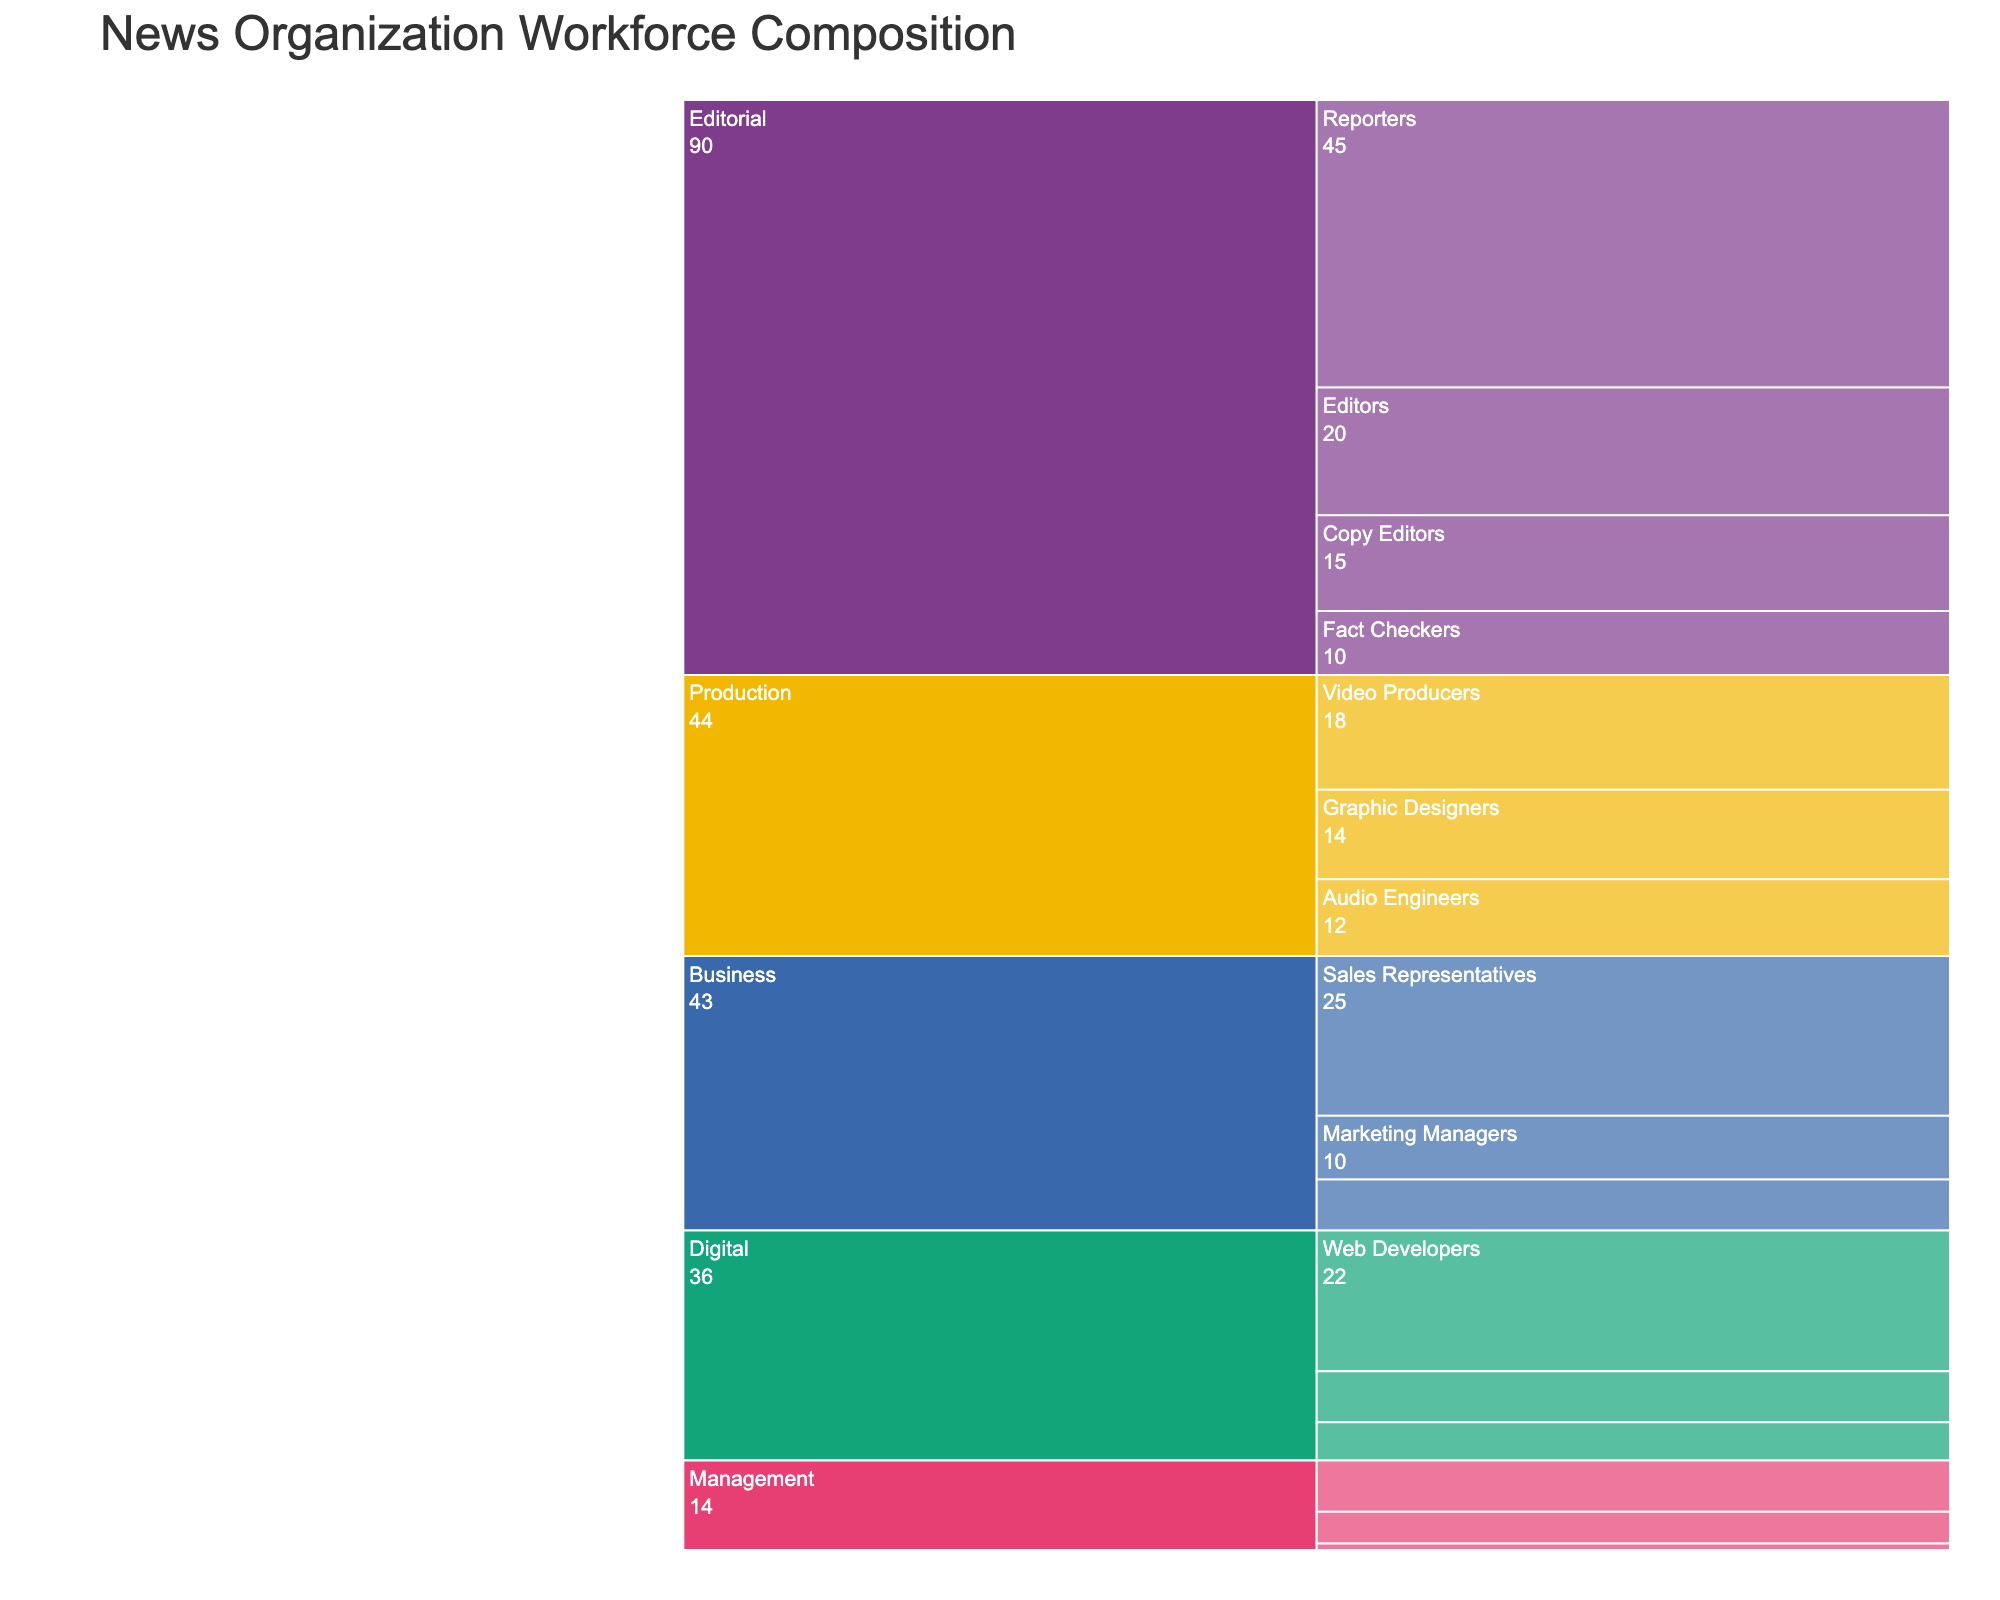What department has the largest workforce? The icicle chart shows departments based on the sum of employees in each job role. The "Editorial" department is the largest as it has the greatest visual area.
Answer: Editorial How many employees work in the Digital department? Sum the number of employees for all job roles in the Digital department. These roles are Web Developers (22), Social Media Managers (8), and SEO Specialists (6). The total is 22 + 8 + 6.
Answer: 36 Which job role has the highest count of employees within the entire organization? The icicle chart displays the employee counts for each job role across different departments. The job role with the highest count is the one with the largest value, which is Reporters in the Editorial department with 45 employees.
Answer: Reporters What is the total number of employees in the organization? Sum the employee count for all job roles across all departments. This involves adding all values in the dataset.
Answer: 227 Which department has the smallest workforce, and how many employees does it have? Identify the department with the smallest visual area on the icicle chart. The "Management" department has the smallest workforce, totaling the counts of Executive Editors (5), Department Heads (8), and CEO (1). The total is 5 + 8 + 1.
Answer: Management, 14 What is the difference in the number of employees between the Editorial and Production departments? Sum the number of employees in each department. Editorial: Reporters (45), Editors (20), Copy Editors (15), Fact Checkers (10) = 45 + 20 + 15 + 10. Production: Video Producers (18), Audio Engineers (12), Graphic Designers (14) = 18 + 12 + 14. The difference is calculated by subtracting the total of Production from Editorial.
Answer: 90 - 44 = 46 Which job role in Business has the second-highest number of employees? Reviewing the job roles in the Business department on the icicle chart, the counts are Sales Representatives (25), Marketing Managers (10), and Accountants (8). The second-highest count is for Marketing Managers with 10 employees.
Answer: Marketing Managers How does the number of employees in Management compare to those in Business? Sum the employees in each department. Management: Executive Editors (5), Department Heads (8), CEO (1) = 14. Business: Sales Representatives (25), Marketing Managers (10), Accountants (8) = 43. Compare these totals where Business is greater than Management.
Answer: Business has 29 more employees than Management How many more employees are in the Editorial department compared to the Digital department? Sum the employees in each department. Editorial: Reporters (45), Editors (20), Copy Editors (15), Fact Checkers (10) = 90. Digital: Web Developers (22), Social Media Managers (8), SEO Specialists (6) = 36. Subtract the total employees in the Digital department from Editorial.
Answer: 90 - 36 = 54 Which job role in the Production department has the least number of employees? Reviewing the job roles in the Production department, the counts are Video Producers (18), Audio Engineers (12), and Graphic Designers (14). The job role with the least number of employees is Audio Engineers with 12.
Answer: Audio Engineers 